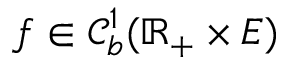Convert formula to latex. <formula><loc_0><loc_0><loc_500><loc_500>f \in \mathcal { C } _ { b } ^ { 1 } ( \mathbb { R } _ { + } \times E )</formula> 